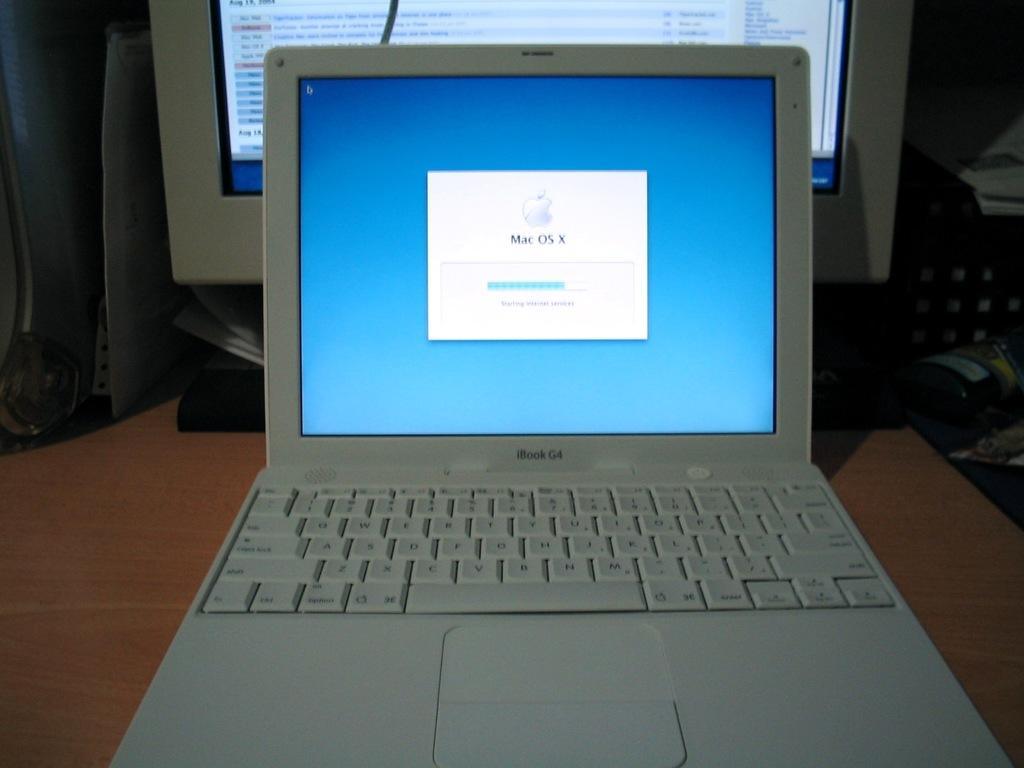<image>
Share a concise interpretation of the image provided. White iBook G4 laptop showing Mac OS X on the screen. 